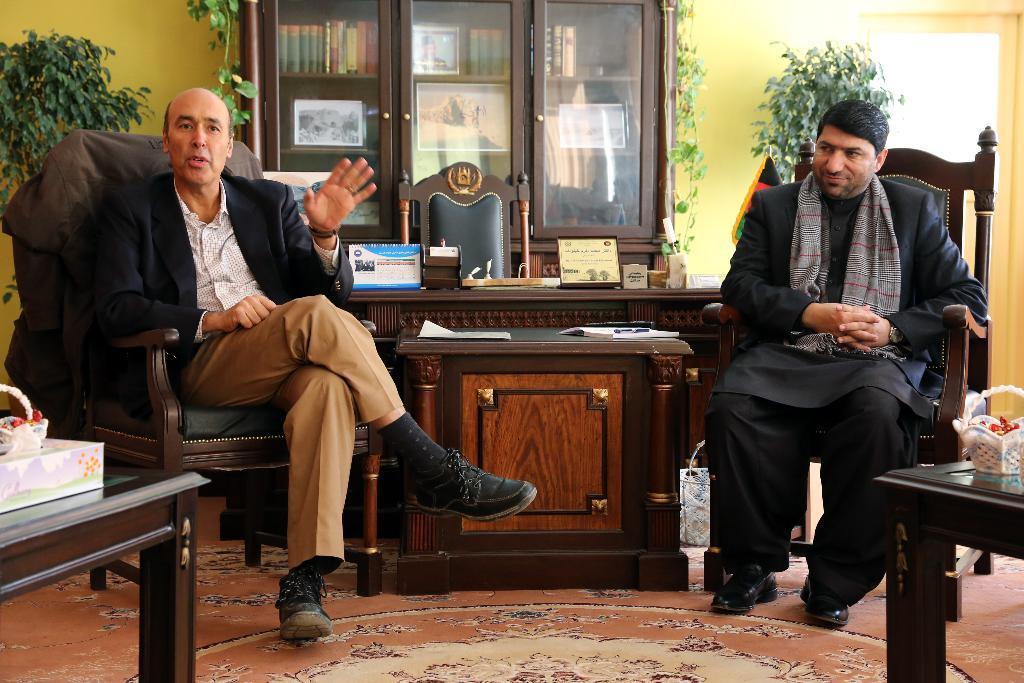In one or two sentences, can you explain what this image depicts? In this image i can see two men are sitting on a chair in front of a table. I can also see there is a cupboard, plants and few other objects. 